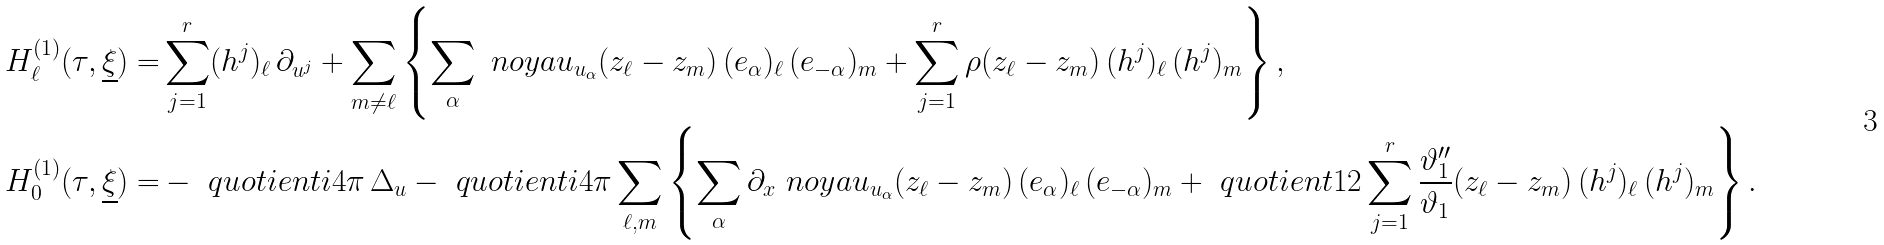<formula> <loc_0><loc_0><loc_500><loc_500>H ^ { ( 1 ) } _ { \ell } ( \tau , \underline { \xi } ) = & \sum _ { j = 1 } ^ { r } ( h ^ { j } ) _ { \ell } \, \partial _ { u ^ { j } } + \sum _ { m \neq \ell } \left \{ \sum _ { \alpha } \ n o y a u _ { u _ { \alpha } } ( z _ { \ell } - z _ { m } ) \, ( e _ { \alpha } ) _ { \ell } \, ( e _ { - \alpha } ) _ { m } + \sum _ { j = 1 } ^ { r } \rho ( z _ { \ell } - z _ { m } ) \, ( h ^ { j } ) _ { \ell } \, ( h ^ { j } ) _ { m } \right \} , \\ H ^ { ( 1 ) } _ { 0 } ( \tau , \underline { \xi } ) = & - \ q u o t i e n t { i } { 4 \pi } \, \Delta _ { u } - \ q u o t i e n t { i } { 4 \pi } \sum _ { \ell , m } \left \{ \sum _ { \alpha } \partial _ { x } \ n o y a u _ { u _ { \alpha } } ( z _ { \ell } - z _ { m } ) \, ( e _ { \alpha } ) _ { \ell } \, ( e _ { - \alpha } ) _ { m } + \ q u o t i e n t { 1 } { 2 } \sum _ { j = 1 } ^ { r } \frac { \vartheta ^ { \prime \prime } _ { 1 } } { \vartheta _ { 1 } } ( z _ { \ell } - z _ { m } ) \, ( h ^ { j } ) _ { \ell } \, ( h ^ { j } ) _ { m } \right \} .</formula> 